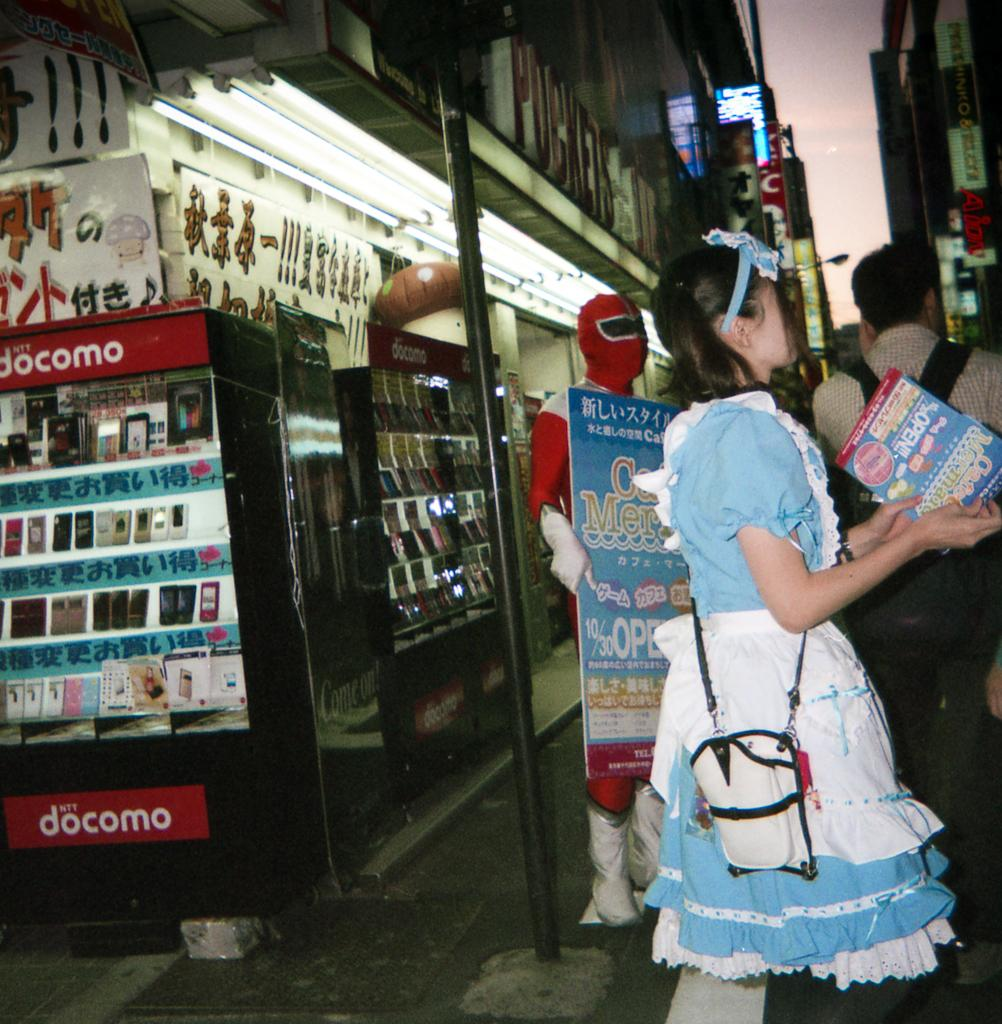<image>
Describe the image concisely. the word docomo is on the red sign 